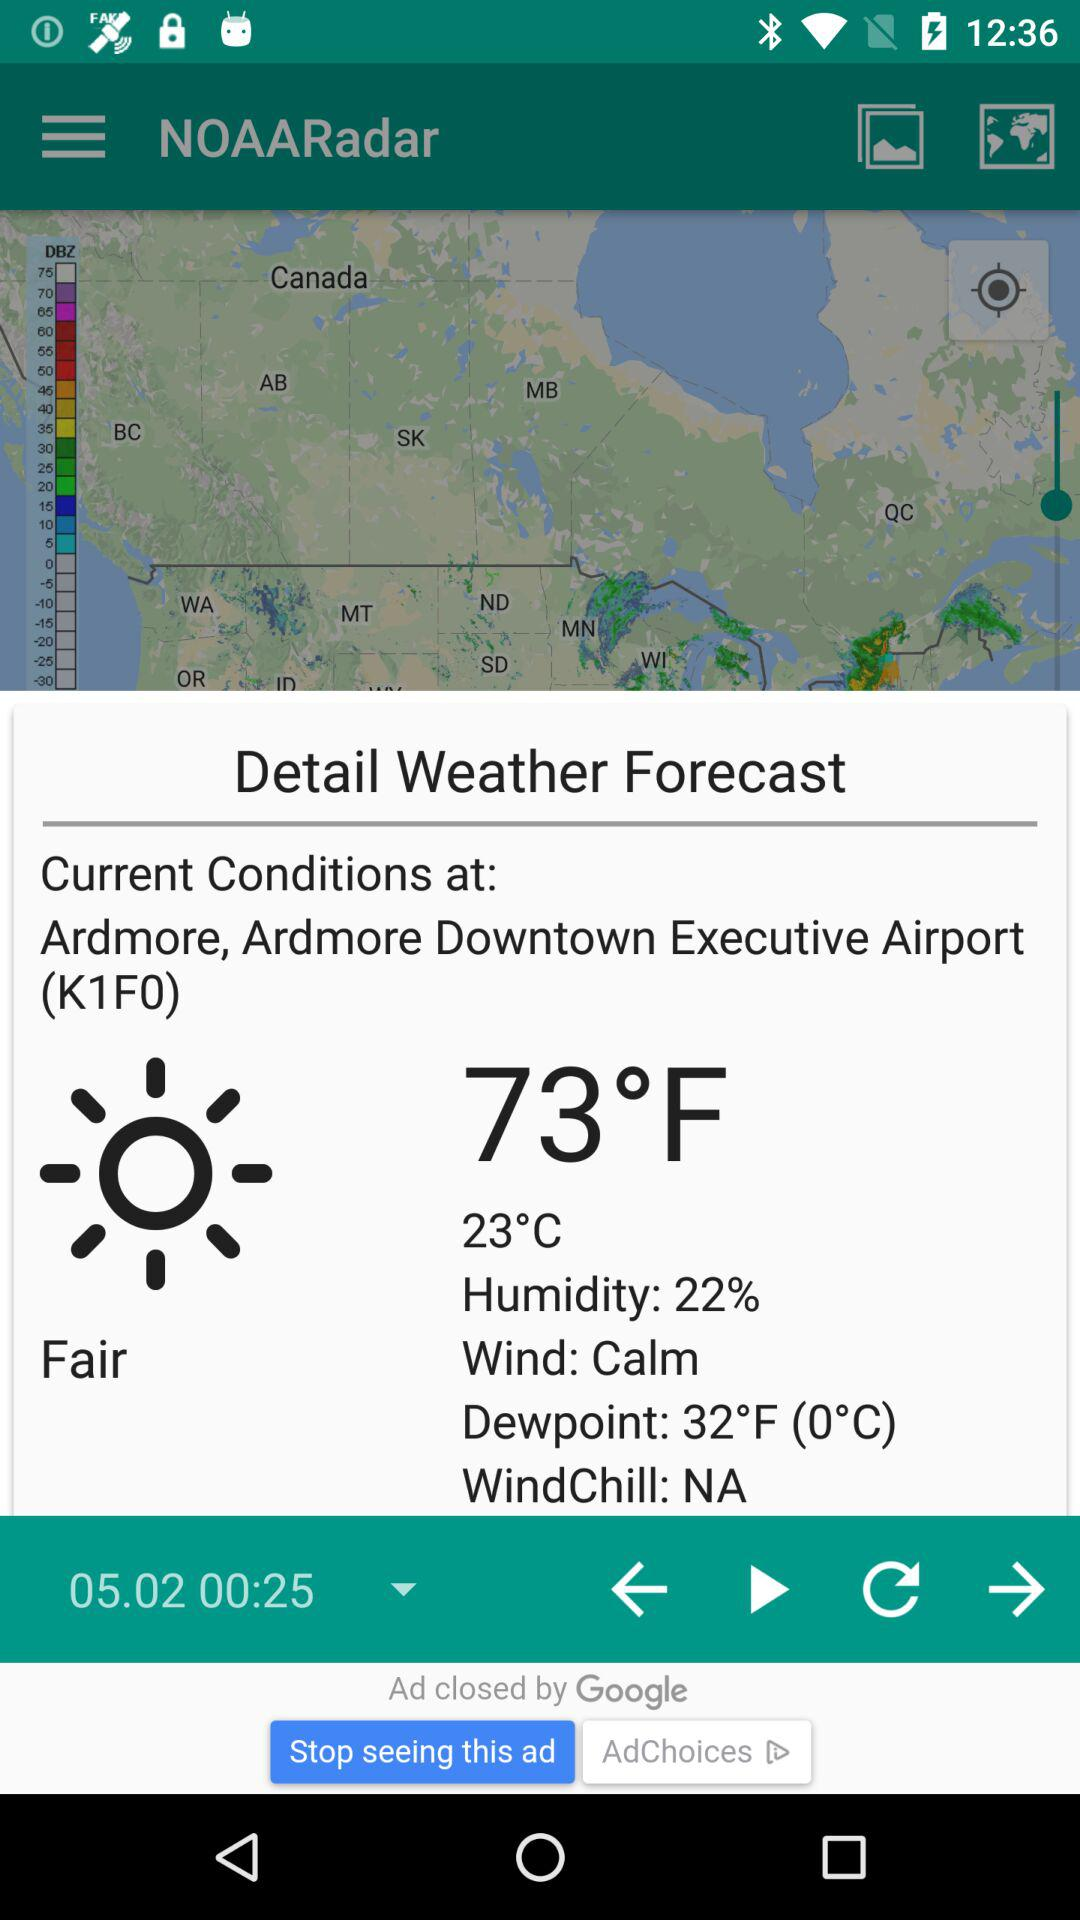How’s the weather? The weather is fair. 